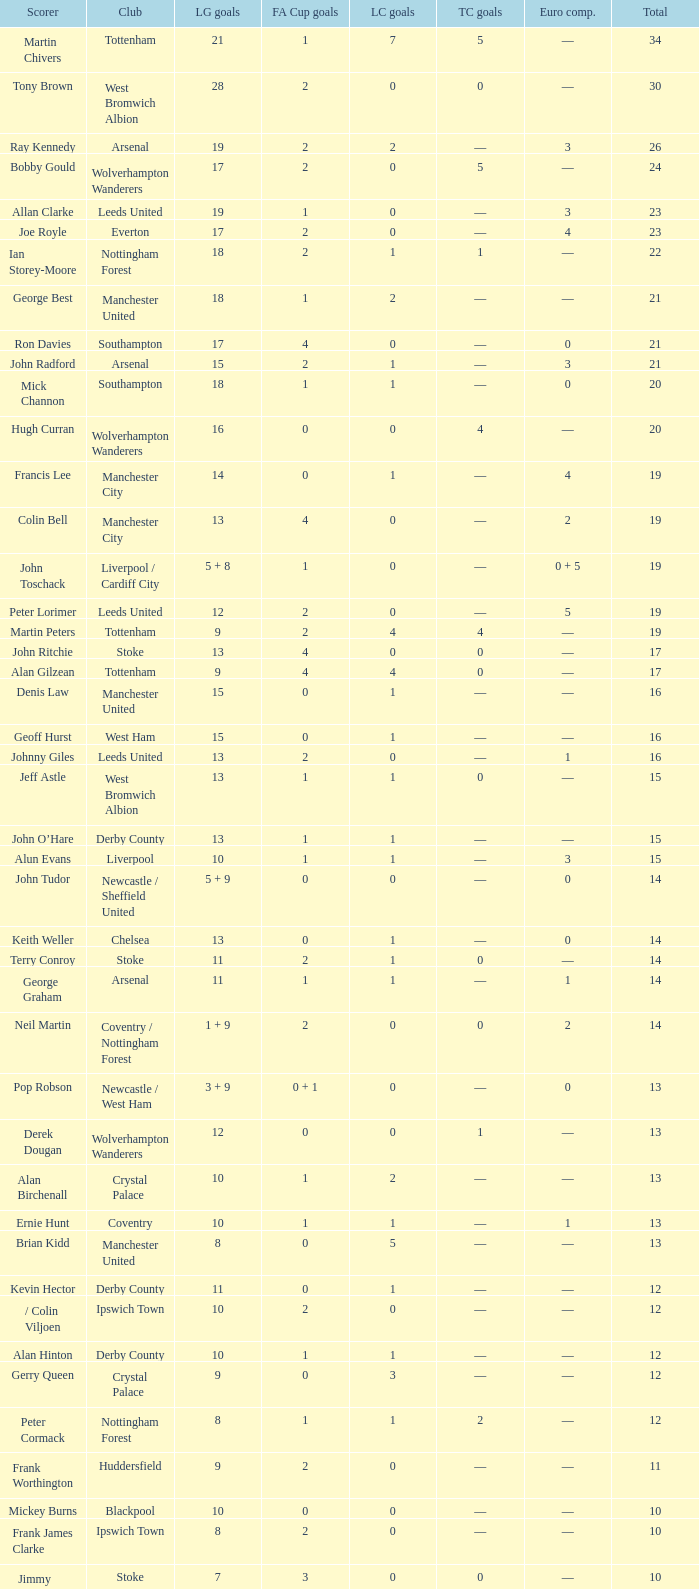What is FA Cup Goals, when Euro Competitions is 1, and when League Goals is 11? 1.0. 